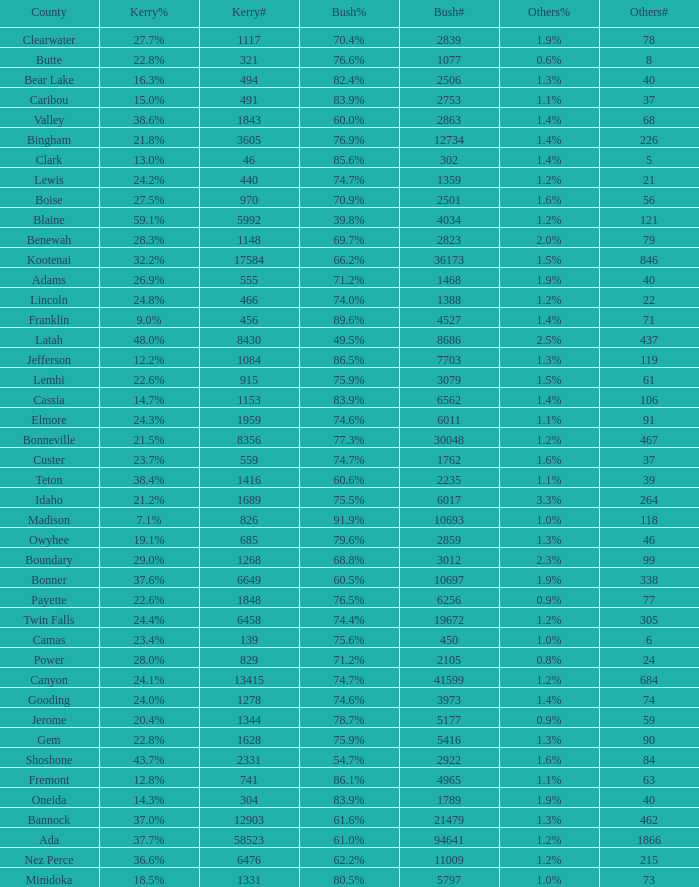What percentage of the votes were for others in the county where 462 people voted that way? 1.3%. 